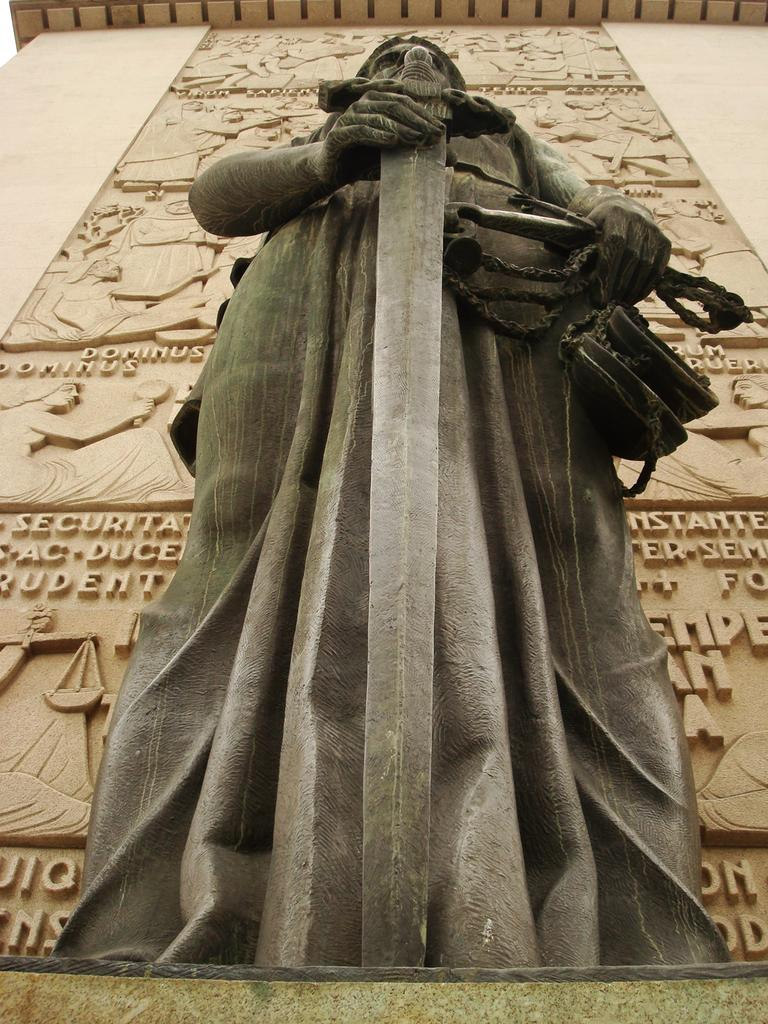What is the main subject in the center of the image? There is a statue in the center of the image. What can be seen in the background of the image? There is a wall in the background of the image. What is written or depicted on the wall? There is text on the wall. What type of degree is the cook holding in the image? There is no cook or degree present in the image; it features a statue and a wall with text. How many astronauts are visible in the image? There are no astronauts or references to space in the image. 